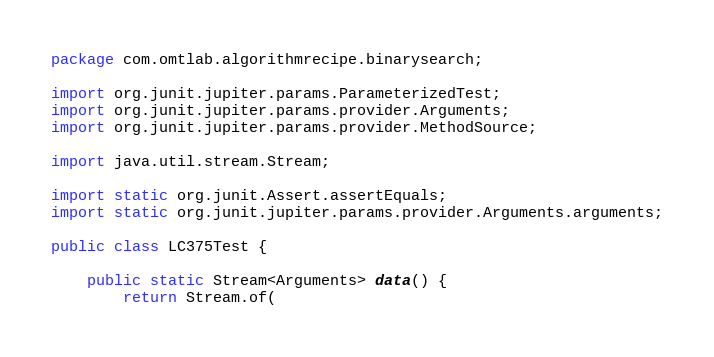<code> <loc_0><loc_0><loc_500><loc_500><_Java_>package com.omtlab.algorithmrecipe.binarysearch;

import org.junit.jupiter.params.ParameterizedTest;
import org.junit.jupiter.params.provider.Arguments;
import org.junit.jupiter.params.provider.MethodSource;

import java.util.stream.Stream;

import static org.junit.Assert.assertEquals;
import static org.junit.jupiter.params.provider.Arguments.arguments;

public class LC375Test {

    public static Stream<Arguments> data() {
        return Stream.of(</code> 